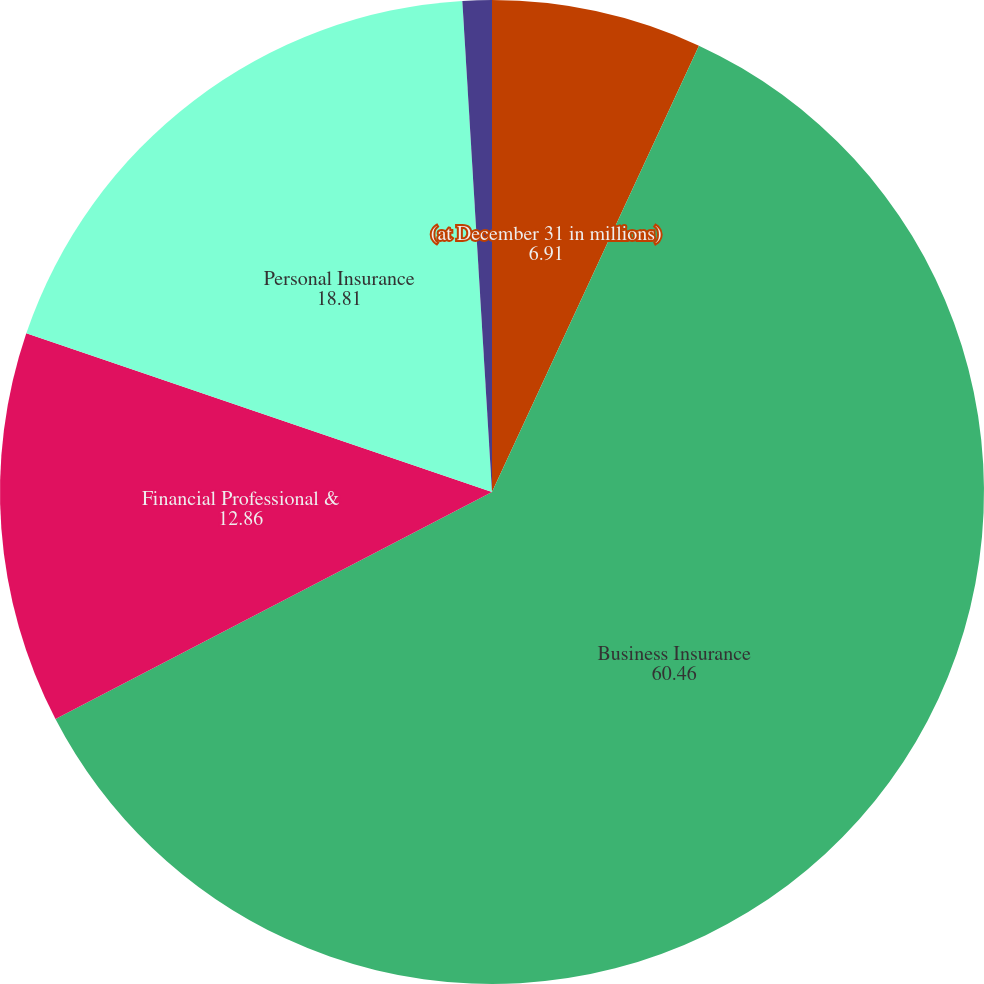Convert chart. <chart><loc_0><loc_0><loc_500><loc_500><pie_chart><fcel>(at December 31 in millions)<fcel>Business Insurance<fcel>Financial Professional &<fcel>Personal Insurance<fcel>Other assets(1)<nl><fcel>6.91%<fcel>60.46%<fcel>12.86%<fcel>18.81%<fcel>0.96%<nl></chart> 